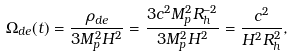Convert formula to latex. <formula><loc_0><loc_0><loc_500><loc_500>\Omega _ { d e } ( t ) = \frac { \rho _ { d e } } { 3 M _ { p } ^ { 2 } H ^ { 2 } } = \frac { 3 c ^ { 2 } M _ { p } ^ { 2 } R _ { h } ^ { - 2 } } { 3 M _ { p } ^ { 2 } H ^ { 2 } } = \frac { c ^ { 2 } } { H ^ { 2 } R _ { h } ^ { 2 } } ,</formula> 